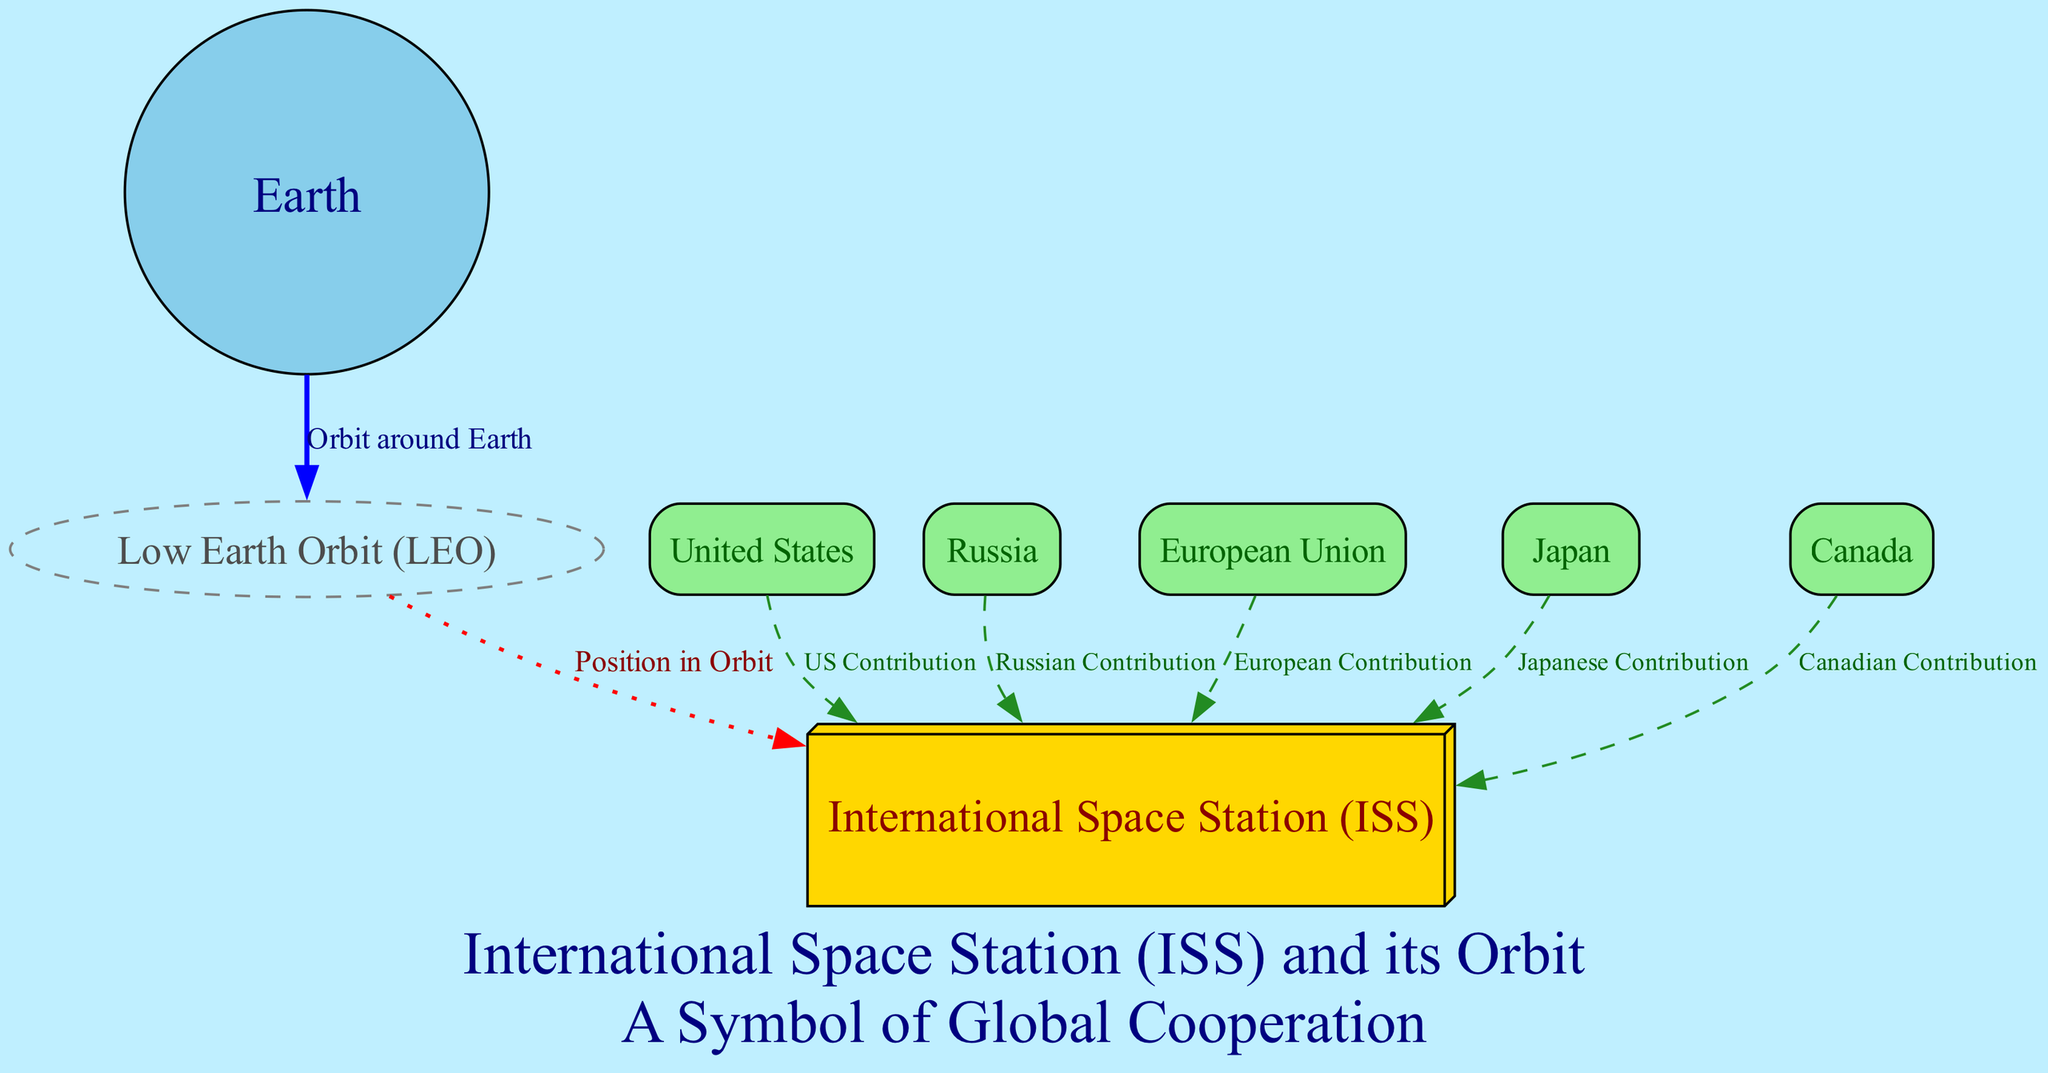What is the label of the node representing Earth? In the diagram, the node that represents Earth has a specific label stated in the data. By reviewing the data provided, we find that the label associated with the Earth node is "Earth."
Answer: Earth How many countries are involved in the ISS collaboration? The diagram details various contributions from different countries. By counting the contributions listed in the edges, we find five countries highlighted: the United States, Russia, the European Union, Japan, and Canada. This totals to five involved countries.
Answer: 5 What is the color of the International Space Station (ISS) node? The diagram describes the ISS node's visual characteristics, including its fill color. The data indicates that the ISS node is filled with gold.
Answer: Gold Which agency is associated with Japan's contribution to the ISS? In the diagram, the edges connect specific countries to their respective contributions. By looking at the labeled edge between Japan and the ISS, we see that Japan's contribution is represented by JAXA.
Answer: JAXA What kind of orbit does the ISS travel in? The orbit specified in the diagram indicates the type of orbit the ISS is involved in. According to the diagram's information, it is categorized as Low Earth Orbit.
Answer: Low Earth Orbit What relationship does the United States have with the ISS? The diagram shows a directed edge from the United States to the ISS, indicating a contribution. From the labeled edge, we understand that the relationship is based on research and international cooperation through NASA.
Answer: Research and international cooperation How often does the ISS orbit the Earth? The diagram specifies the frequency of the ISS's orbit around the Earth. By referring to the description provided in the edges, we note that it orbits approximately every 90 minutes.
Answer: 90 minutes What shape is the node labeled "Low Earth Orbit"? The diagram specifies the geometrical representation of the Low Earth Orbit node within its attributes. By examining the node details, we determine that it is represented in the shape of an ellipse.
Answer: Ellipse Which country is home to the Canadian Space Agency (CSA)? The diagram outlines the contributions to the ISS and directly links countries to their respective space agencies. By looking at Canada’s labeled connection, we conclude that Canada hosts the CSA.
Answer: Canada 